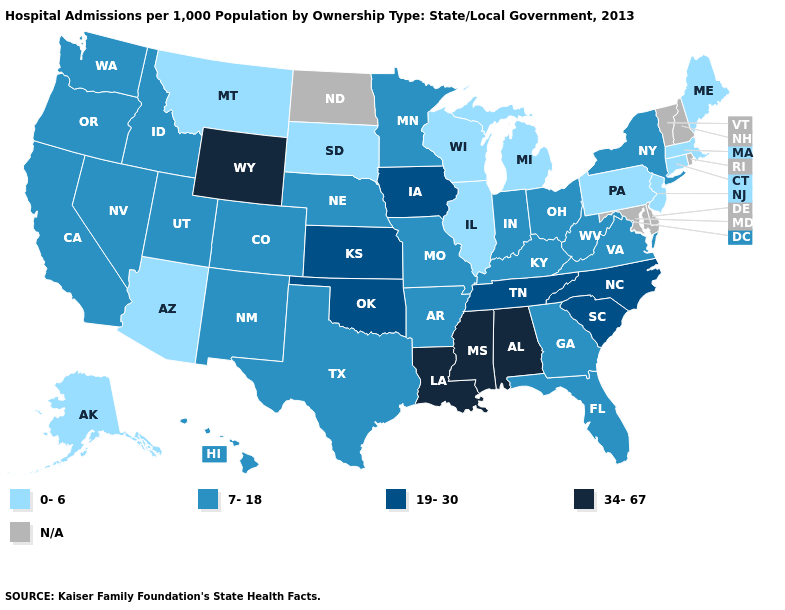What is the value of Alabama?
Answer briefly. 34-67. What is the value of Illinois?
Concise answer only. 0-6. Which states hav the highest value in the South?
Give a very brief answer. Alabama, Louisiana, Mississippi. How many symbols are there in the legend?
Short answer required. 5. Name the states that have a value in the range 34-67?
Give a very brief answer. Alabama, Louisiana, Mississippi, Wyoming. Among the states that border Nevada , which have the highest value?
Write a very short answer. California, Idaho, Oregon, Utah. What is the value of Massachusetts?
Give a very brief answer. 0-6. What is the lowest value in states that border Oregon?
Be succinct. 7-18. What is the lowest value in the MidWest?
Give a very brief answer. 0-6. Among the states that border New Mexico , does Texas have the highest value?
Short answer required. No. Name the states that have a value in the range 19-30?
Concise answer only. Iowa, Kansas, North Carolina, Oklahoma, South Carolina, Tennessee. What is the lowest value in the Northeast?
Write a very short answer. 0-6. What is the value of Tennessee?
Write a very short answer. 19-30. Among the states that border Nebraska , does Iowa have the lowest value?
Quick response, please. No. Name the states that have a value in the range 7-18?
Keep it brief. Arkansas, California, Colorado, Florida, Georgia, Hawaii, Idaho, Indiana, Kentucky, Minnesota, Missouri, Nebraska, Nevada, New Mexico, New York, Ohio, Oregon, Texas, Utah, Virginia, Washington, West Virginia. 